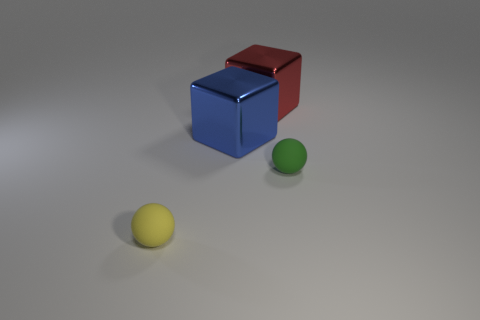Add 1 small rubber cylinders. How many objects exist? 5 Subtract all red blocks. How many blocks are left? 1 Add 3 small things. How many small things exist? 5 Subtract 0 brown balls. How many objects are left? 4 Subtract all brown cubes. Subtract all green spheres. How many cubes are left? 2 Subtract all large blue things. Subtract all small things. How many objects are left? 1 Add 1 large blocks. How many large blocks are left? 3 